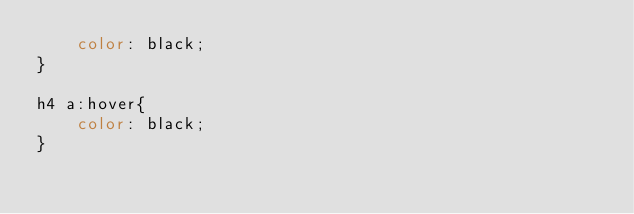Convert code to text. <code><loc_0><loc_0><loc_500><loc_500><_CSS_>    color: black;
}

h4 a:hover{
    color: black;
}</code> 